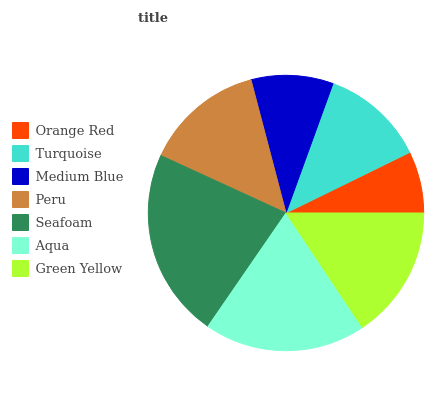Is Orange Red the minimum?
Answer yes or no. Yes. Is Seafoam the maximum?
Answer yes or no. Yes. Is Turquoise the minimum?
Answer yes or no. No. Is Turquoise the maximum?
Answer yes or no. No. Is Turquoise greater than Orange Red?
Answer yes or no. Yes. Is Orange Red less than Turquoise?
Answer yes or no. Yes. Is Orange Red greater than Turquoise?
Answer yes or no. No. Is Turquoise less than Orange Red?
Answer yes or no. No. Is Peru the high median?
Answer yes or no. Yes. Is Peru the low median?
Answer yes or no. Yes. Is Turquoise the high median?
Answer yes or no. No. Is Orange Red the low median?
Answer yes or no. No. 